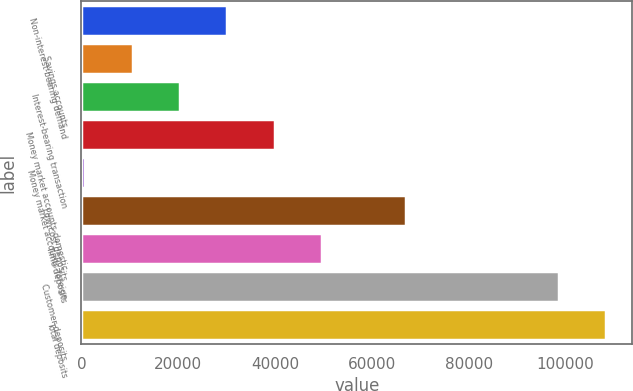Convert chart to OTSL. <chart><loc_0><loc_0><loc_500><loc_500><bar_chart><fcel>Non-interest-bearing demand<fcel>Savings accounts<fcel>Interest-bearing transaction<fcel>Money market accounts-domestic<fcel>Money market accounts-foreign<fcel>Low-cost deposits<fcel>Time deposits<fcel>Customer deposits<fcel>Total deposits<nl><fcel>30140.2<fcel>10557.4<fcel>20348.8<fcel>39931.6<fcel>766<fcel>67125<fcel>49723<fcel>98593<fcel>108384<nl></chart> 